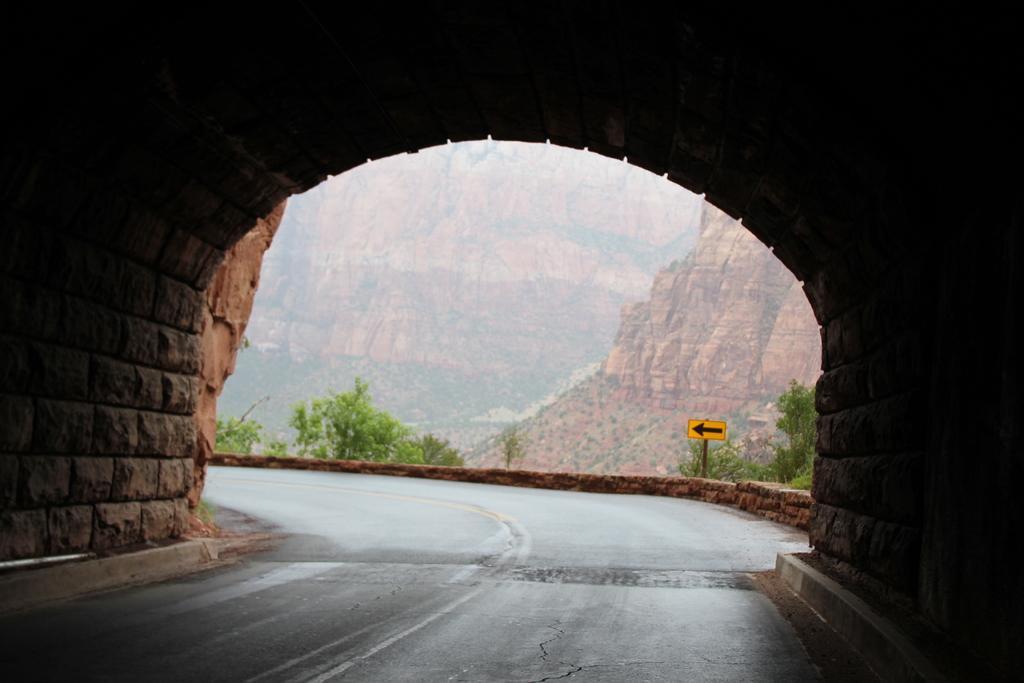Could you give a brief overview of what you see in this image? In this image I can see a road, background I can see few plants in green color and a yellow color sign and I can see the rock in brown color. 